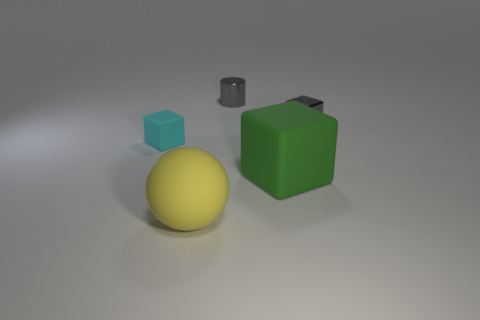There is a tiny metallic object that is right of the gray object that is left of the tiny block that is right of the cyan matte object; what color is it? The tiny metallic object situated to the right of the gray object and to the left of the small block on the right of the cyan matte object is gray in color, exhibiting a cool, understated tone that is typical of metal items. 